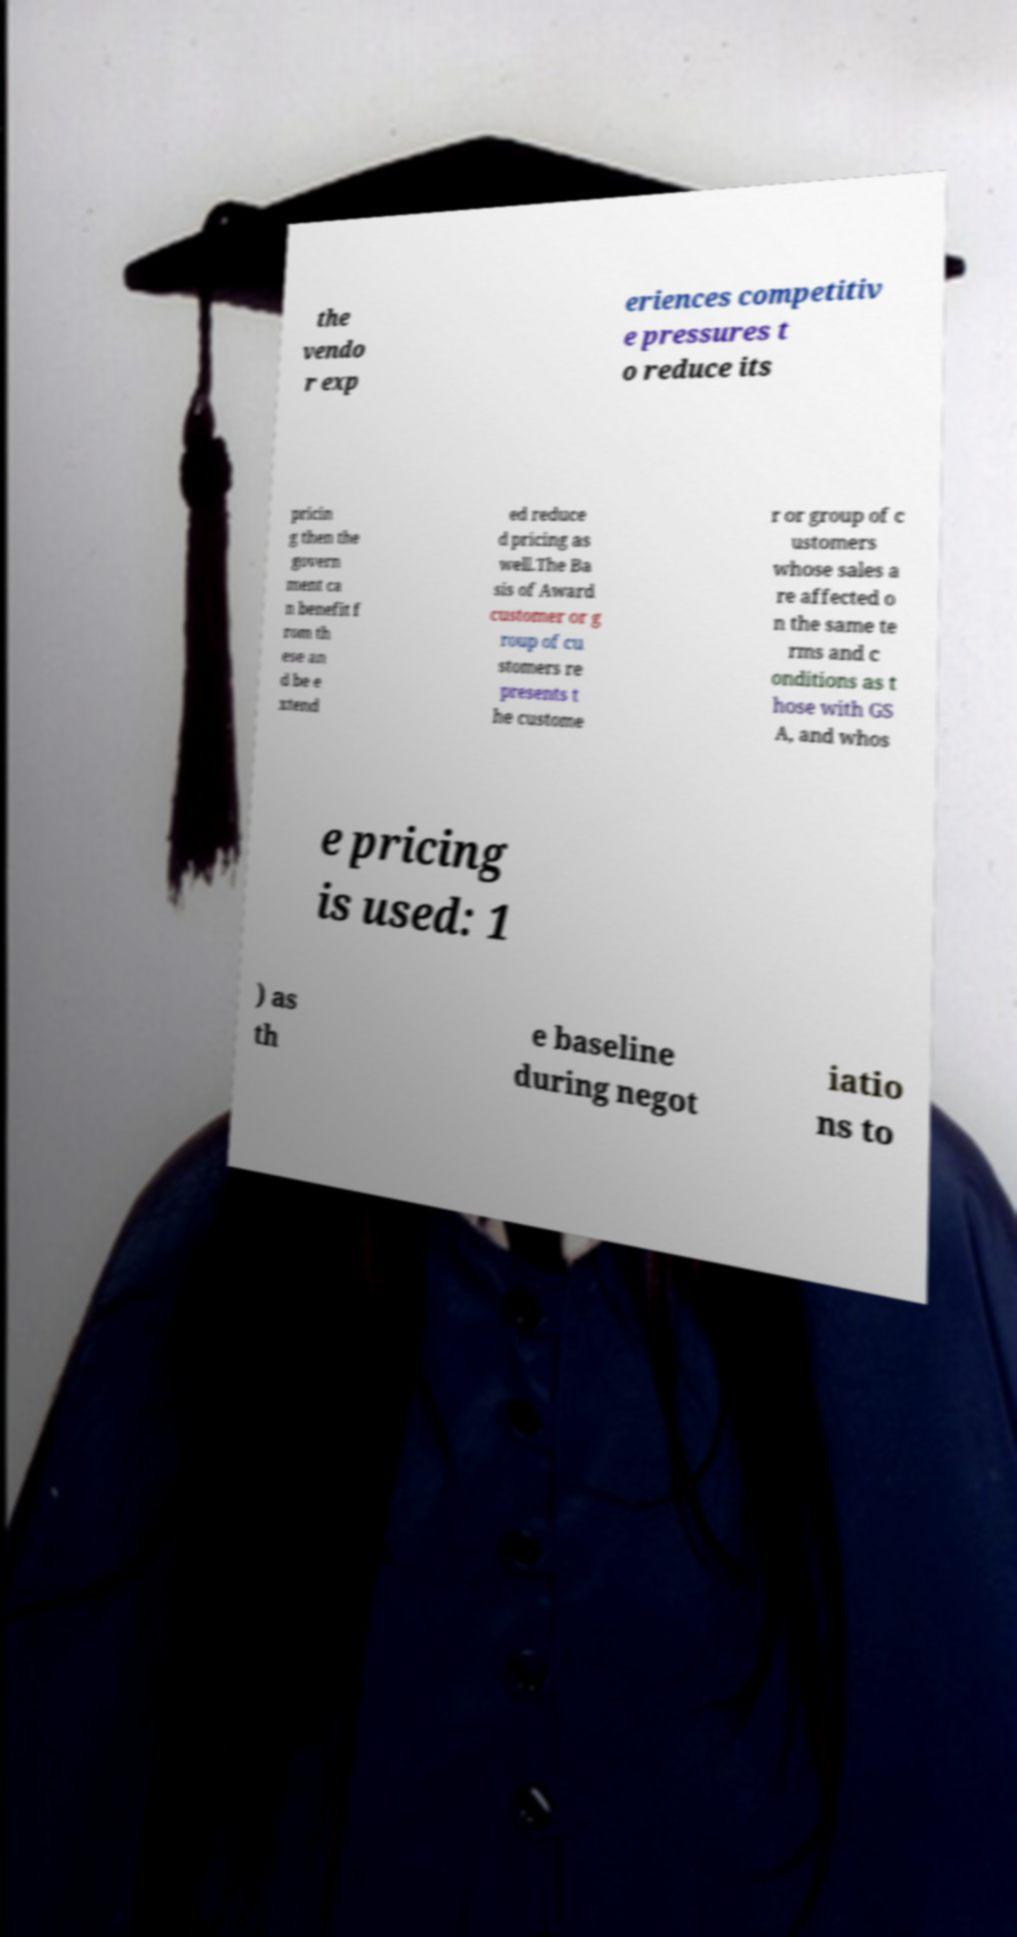Could you assist in decoding the text presented in this image and type it out clearly? the vendo r exp eriences competitiv e pressures t o reduce its pricin g then the govern ment ca n benefit f rom th ese an d be e xtend ed reduce d pricing as well.The Ba sis of Award customer or g roup of cu stomers re presents t he custome r or group of c ustomers whose sales a re affected o n the same te rms and c onditions as t hose with GS A, and whos e pricing is used: 1 ) as th e baseline during negot iatio ns to 